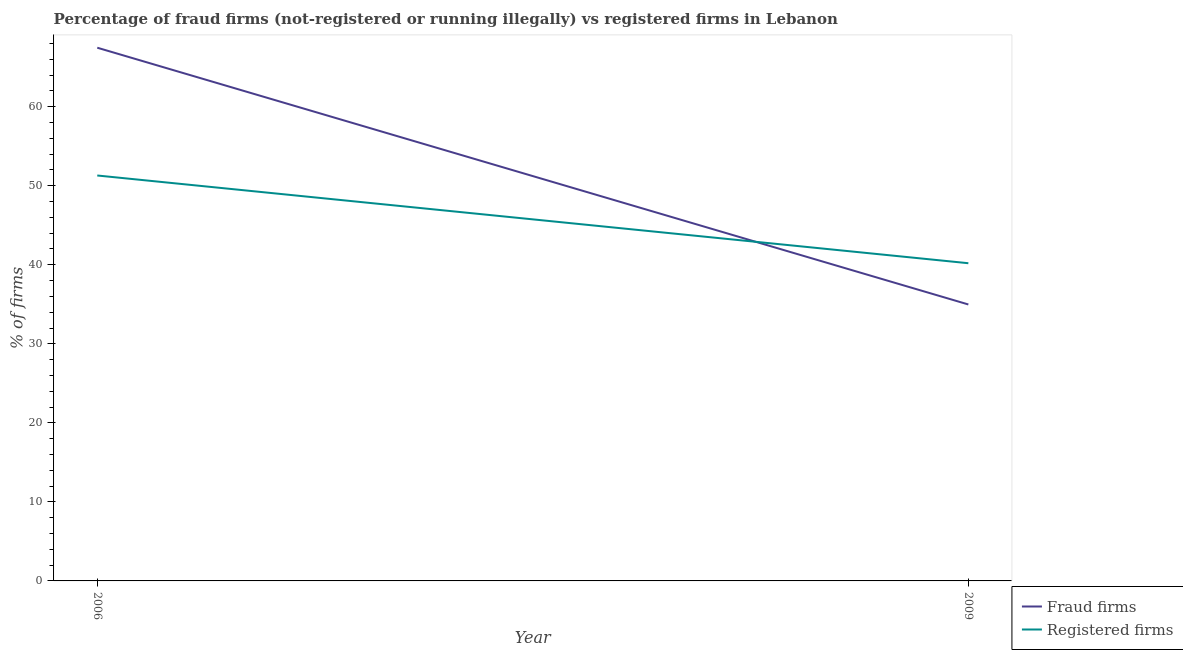Does the line corresponding to percentage of fraud firms intersect with the line corresponding to percentage of registered firms?
Provide a short and direct response. Yes. Is the number of lines equal to the number of legend labels?
Keep it short and to the point. Yes. What is the percentage of fraud firms in 2009?
Keep it short and to the point. 34.98. Across all years, what is the maximum percentage of registered firms?
Provide a short and direct response. 51.3. Across all years, what is the minimum percentage of registered firms?
Give a very brief answer. 40.2. In which year was the percentage of registered firms maximum?
Keep it short and to the point. 2006. In which year was the percentage of fraud firms minimum?
Ensure brevity in your answer.  2009. What is the total percentage of registered firms in the graph?
Provide a succinct answer. 91.5. What is the difference between the percentage of registered firms in 2006 and that in 2009?
Provide a short and direct response. 11.1. What is the difference between the percentage of fraud firms in 2009 and the percentage of registered firms in 2006?
Your answer should be very brief. -16.32. What is the average percentage of registered firms per year?
Give a very brief answer. 45.75. In the year 2006, what is the difference between the percentage of fraud firms and percentage of registered firms?
Make the answer very short. 16.17. In how many years, is the percentage of registered firms greater than 32 %?
Make the answer very short. 2. What is the ratio of the percentage of registered firms in 2006 to that in 2009?
Provide a succinct answer. 1.28. Are the values on the major ticks of Y-axis written in scientific E-notation?
Your answer should be very brief. No. Does the graph contain any zero values?
Your answer should be compact. No. How many legend labels are there?
Give a very brief answer. 2. What is the title of the graph?
Your response must be concise. Percentage of fraud firms (not-registered or running illegally) vs registered firms in Lebanon. Does "Primary" appear as one of the legend labels in the graph?
Provide a succinct answer. No. What is the label or title of the Y-axis?
Provide a succinct answer. % of firms. What is the % of firms in Fraud firms in 2006?
Your answer should be compact. 67.47. What is the % of firms in Registered firms in 2006?
Give a very brief answer. 51.3. What is the % of firms of Fraud firms in 2009?
Give a very brief answer. 34.98. What is the % of firms of Registered firms in 2009?
Your answer should be compact. 40.2. Across all years, what is the maximum % of firms in Fraud firms?
Your answer should be very brief. 67.47. Across all years, what is the maximum % of firms in Registered firms?
Provide a succinct answer. 51.3. Across all years, what is the minimum % of firms of Fraud firms?
Your answer should be compact. 34.98. Across all years, what is the minimum % of firms in Registered firms?
Give a very brief answer. 40.2. What is the total % of firms of Fraud firms in the graph?
Provide a succinct answer. 102.45. What is the total % of firms in Registered firms in the graph?
Keep it short and to the point. 91.5. What is the difference between the % of firms in Fraud firms in 2006 and that in 2009?
Keep it short and to the point. 32.49. What is the difference between the % of firms in Registered firms in 2006 and that in 2009?
Provide a short and direct response. 11.1. What is the difference between the % of firms of Fraud firms in 2006 and the % of firms of Registered firms in 2009?
Keep it short and to the point. 27.27. What is the average % of firms of Fraud firms per year?
Ensure brevity in your answer.  51.23. What is the average % of firms in Registered firms per year?
Your answer should be compact. 45.75. In the year 2006, what is the difference between the % of firms of Fraud firms and % of firms of Registered firms?
Offer a terse response. 16.17. In the year 2009, what is the difference between the % of firms in Fraud firms and % of firms in Registered firms?
Make the answer very short. -5.22. What is the ratio of the % of firms of Fraud firms in 2006 to that in 2009?
Your answer should be very brief. 1.93. What is the ratio of the % of firms in Registered firms in 2006 to that in 2009?
Offer a terse response. 1.28. What is the difference between the highest and the second highest % of firms in Fraud firms?
Make the answer very short. 32.49. What is the difference between the highest and the second highest % of firms in Registered firms?
Provide a short and direct response. 11.1. What is the difference between the highest and the lowest % of firms of Fraud firms?
Offer a terse response. 32.49. 